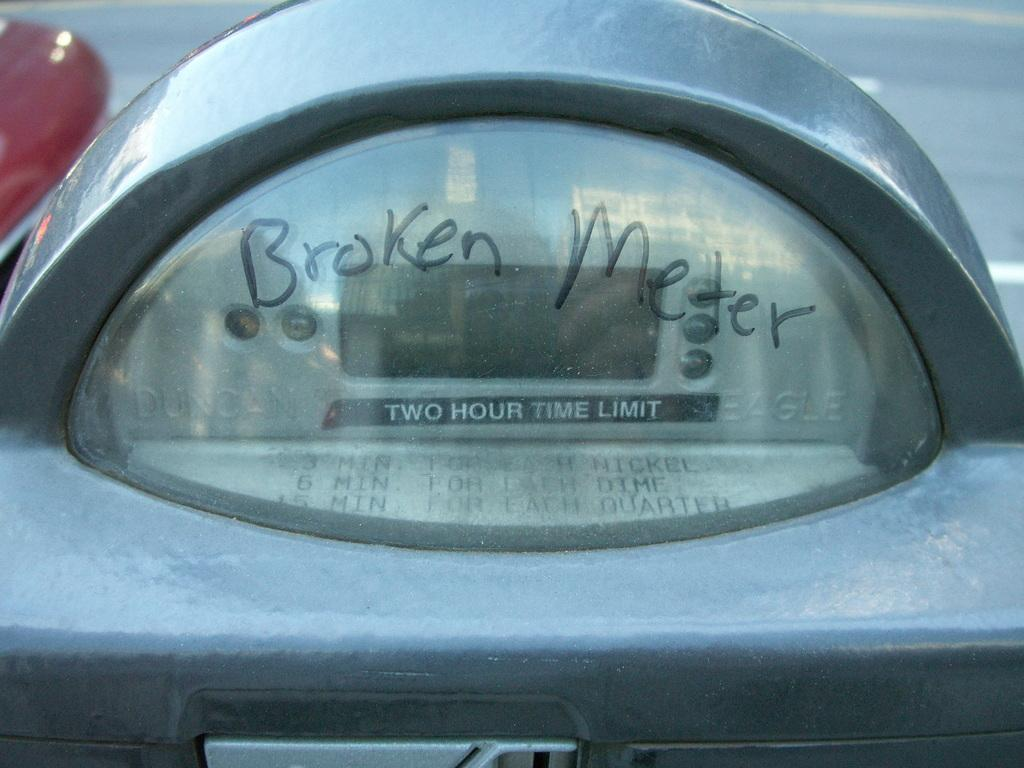<image>
Provide a brief description of the given image. A parking meter that has a two hour time limit has Broken Meter written on it. 